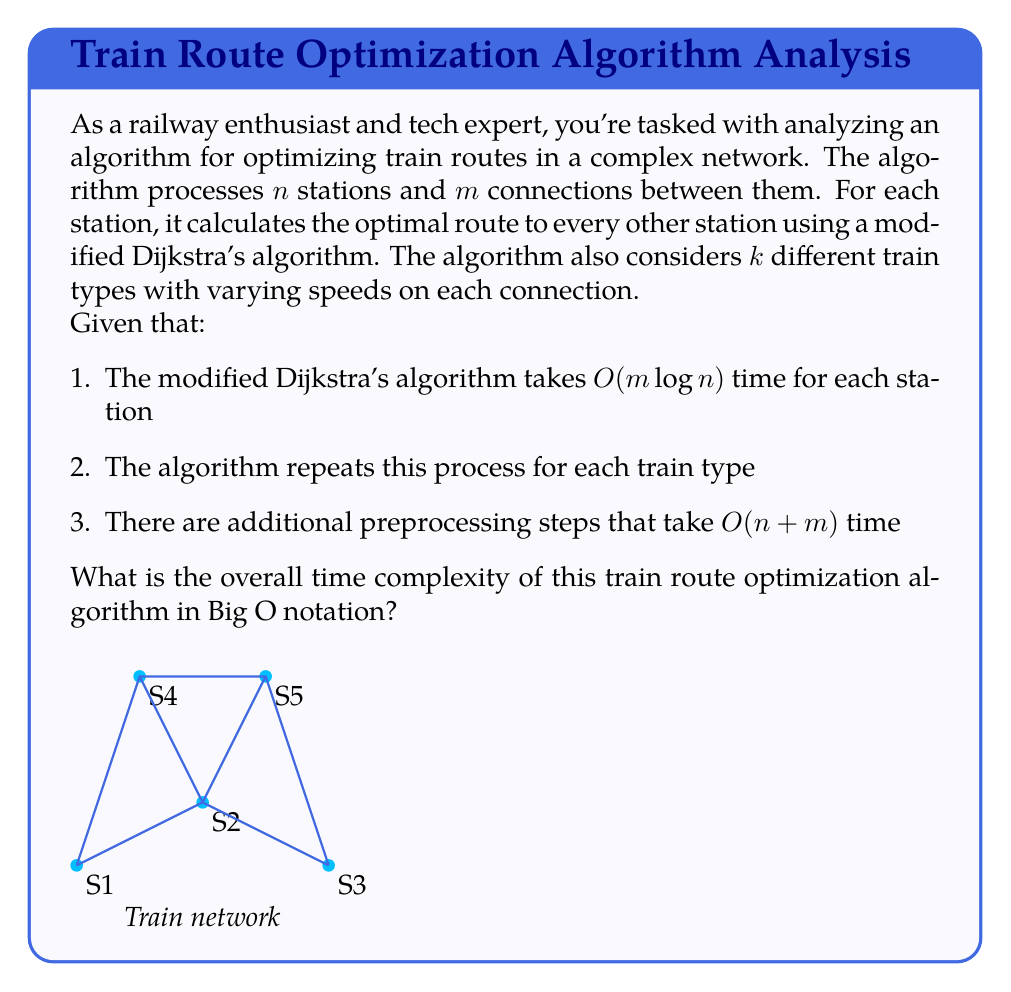Provide a solution to this math problem. Let's break down the algorithm and analyze its time complexity step by step:

1. Preprocessing: $O(n + m)$
   This step is negligible compared to the main algorithm, but we'll include it in our final calculation.

2. Main algorithm:
   a. For each station (total $n$ stations):
      - Run modified Dijkstra's algorithm: $O(m \log n)$
   b. Repeat for each train type (total $k$ types)

   The time complexity for the main part is:
   $$O(n \cdot k \cdot m \log n)$$

3. Combining preprocessing and main algorithm:
   $$O(n + m) + O(n \cdot k \cdot m \log n)$$

4. Simplifying:
   The $O(n + m)$ term is dominated by $O(n \cdot k \cdot m \log n)$, so we can drop it.

5. Final time complexity:
   $$O(n \cdot k \cdot m \log n)$$

This represents the worst-case scenario where the algorithm needs to process all stations, all train types, and all connections for each calculation.
Answer: $O(n \cdot k \cdot m \log n)$ 